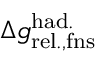Convert formula to latex. <formula><loc_0><loc_0><loc_500><loc_500>\Delta { g } _ { r e l . , f n s } ^ { h a d . }</formula> 